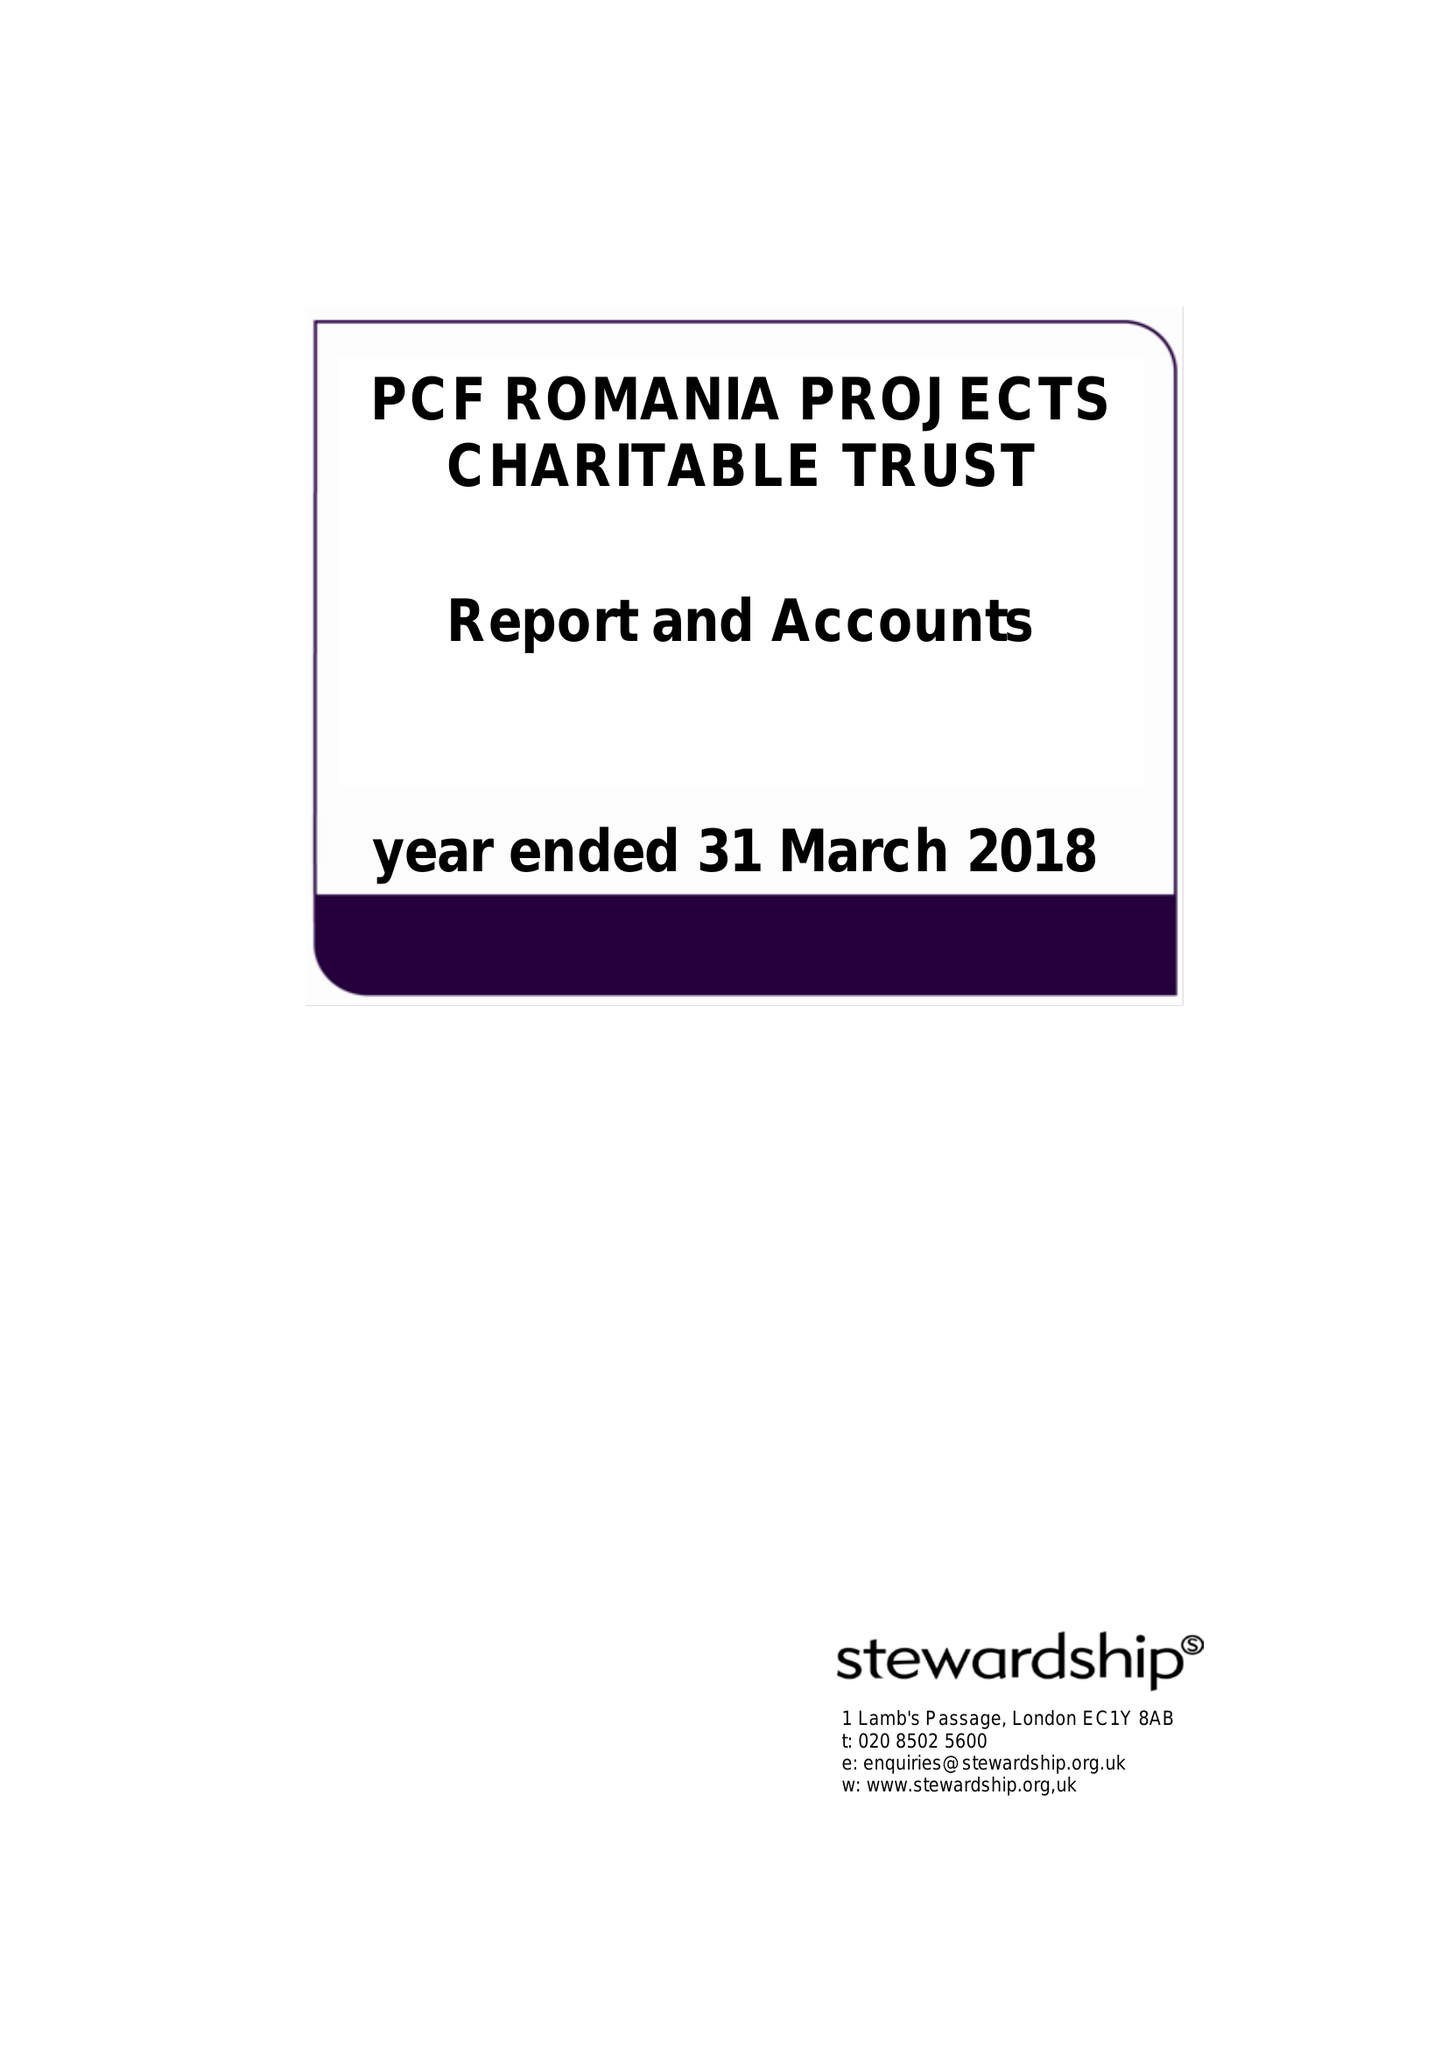What is the value for the address__post_town?
Answer the question using a single word or phrase. WOLVERHAMPTON 